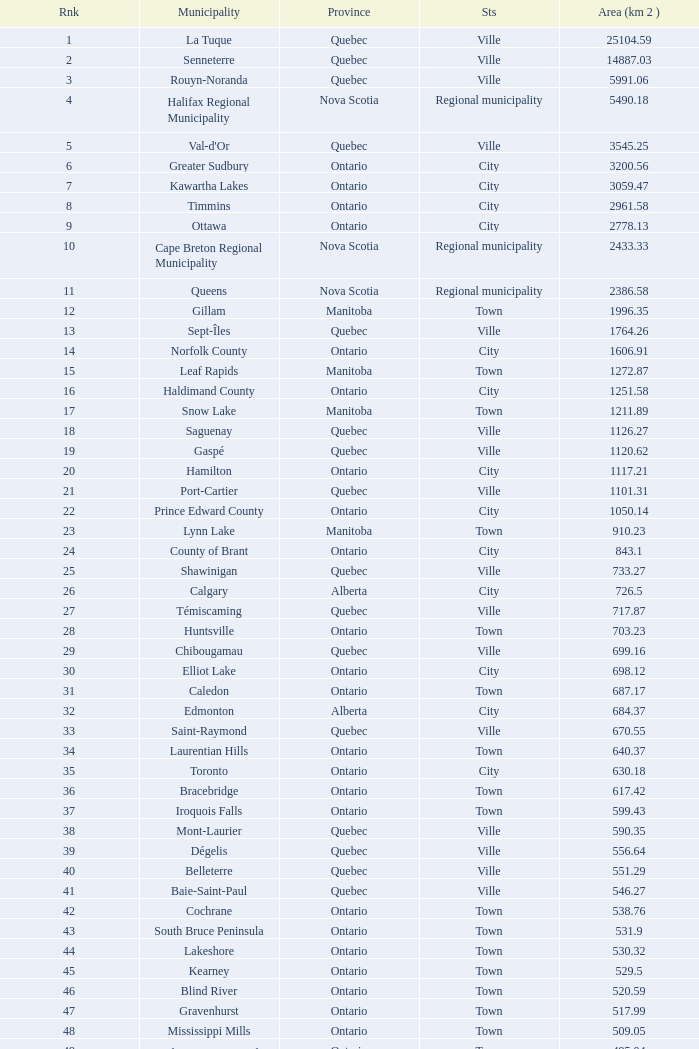What is the listed Status that has the Province of Ontario and Rank of 86? Town. 